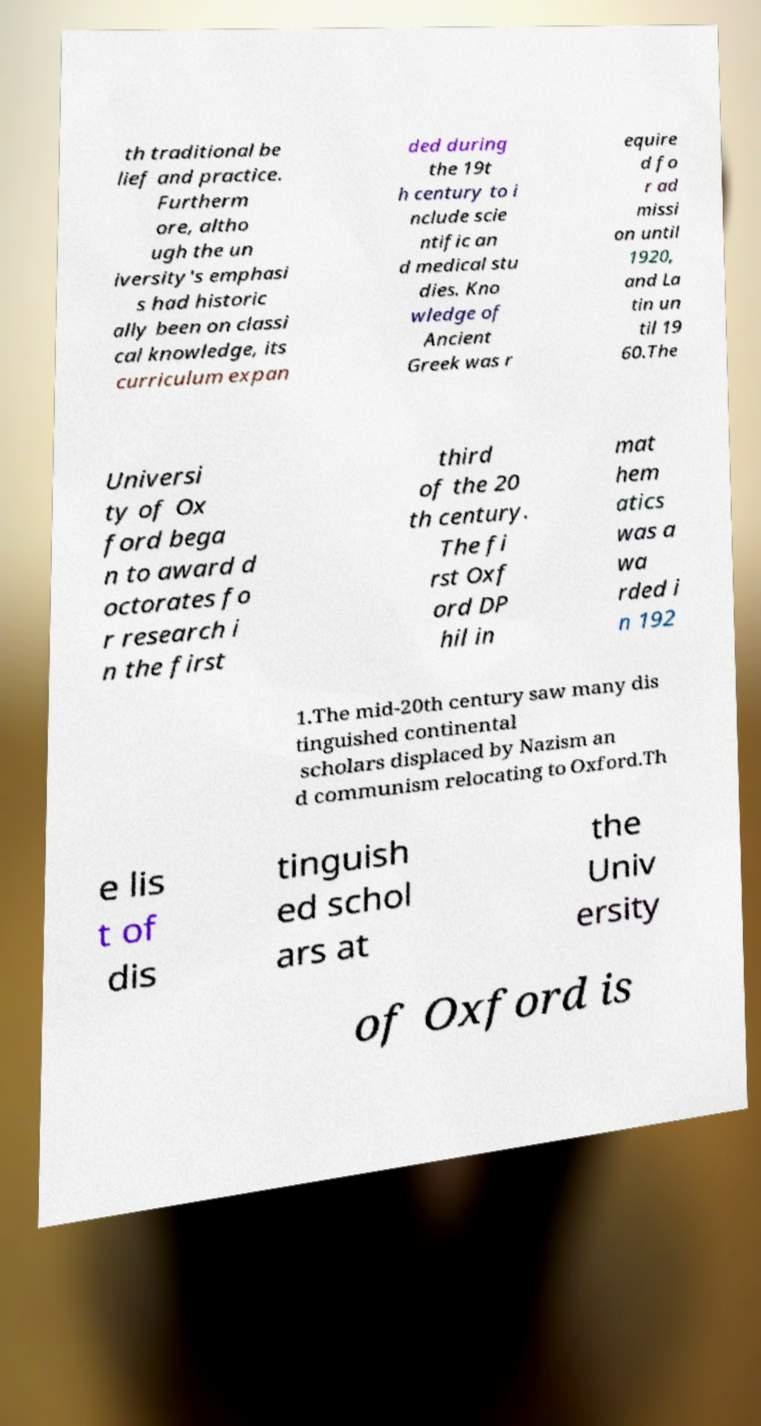Please identify and transcribe the text found in this image. th traditional be lief and practice. Furtherm ore, altho ugh the un iversity's emphasi s had historic ally been on classi cal knowledge, its curriculum expan ded during the 19t h century to i nclude scie ntific an d medical stu dies. Kno wledge of Ancient Greek was r equire d fo r ad missi on until 1920, and La tin un til 19 60.The Universi ty of Ox ford bega n to award d octorates fo r research i n the first third of the 20 th century. The fi rst Oxf ord DP hil in mat hem atics was a wa rded i n 192 1.The mid-20th century saw many dis tinguished continental scholars displaced by Nazism an d communism relocating to Oxford.Th e lis t of dis tinguish ed schol ars at the Univ ersity of Oxford is 